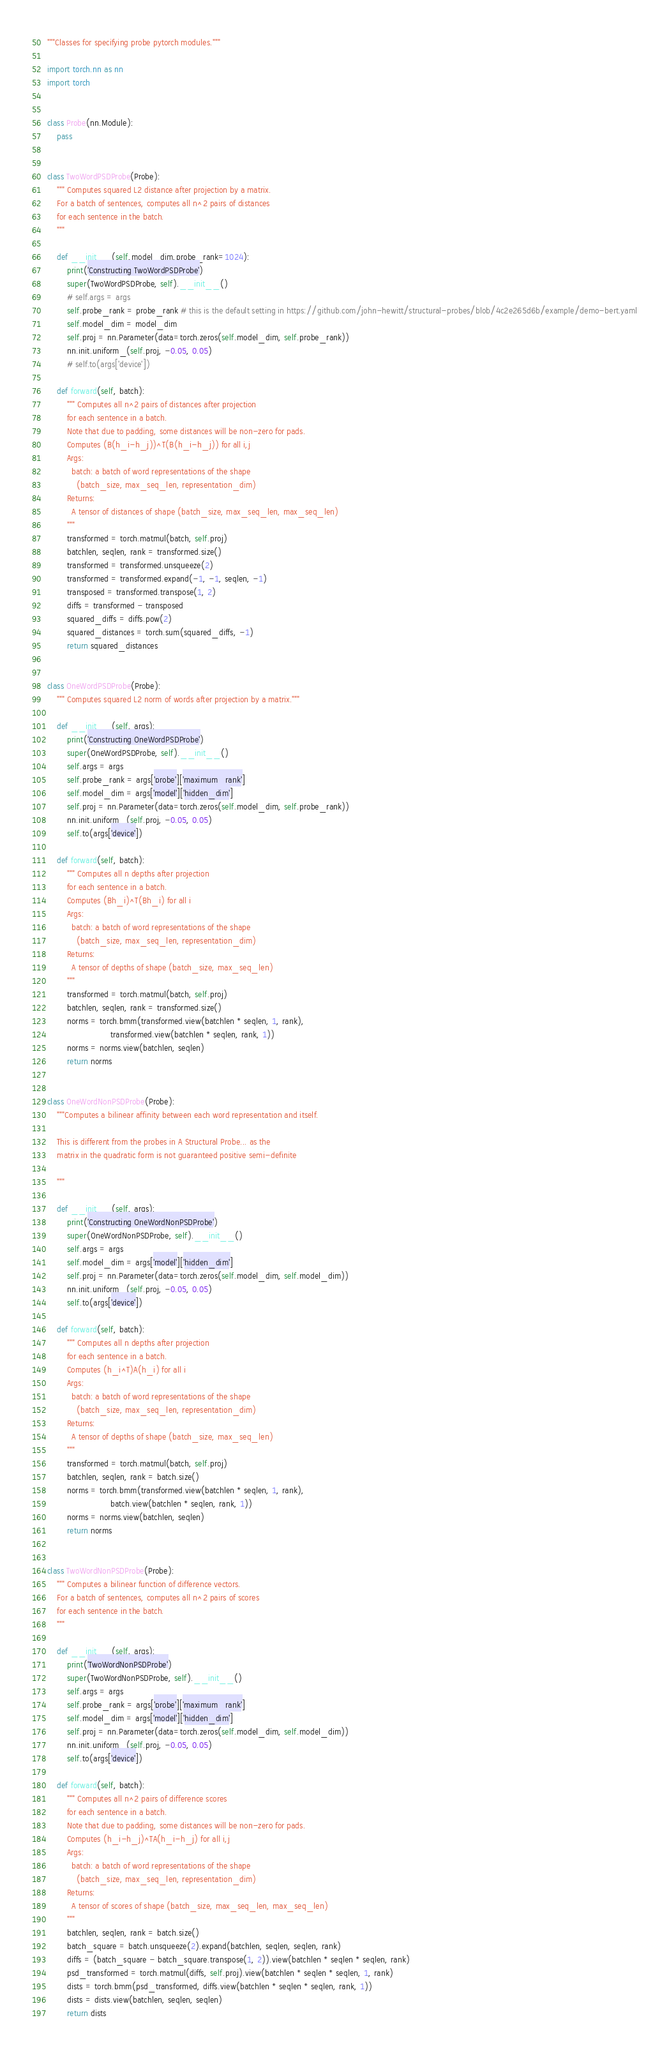<code> <loc_0><loc_0><loc_500><loc_500><_Python_>"""Classes for specifying probe pytorch modules."""

import torch.nn as nn
import torch


class Probe(nn.Module):
    pass


class TwoWordPSDProbe(Probe):
    """ Computes squared L2 distance after projection by a matrix.
    For a batch of sentences, computes all n^2 pairs of distances
    for each sentence in the batch.
    """

    def __init__(self,model_dim,probe_rank=1024):
        print('Constructing TwoWordPSDProbe')
        super(TwoWordPSDProbe, self).__init__()
        # self.args = args
        self.probe_rank = probe_rank # this is the default setting in https://github.com/john-hewitt/structural-probes/blob/4c2e265d6b/example/demo-bert.yaml
        self.model_dim = model_dim
        self.proj = nn.Parameter(data=torch.zeros(self.model_dim, self.probe_rank))
        nn.init.uniform_(self.proj, -0.05, 0.05)
        # self.to(args['device'])

    def forward(self, batch):
        """ Computes all n^2 pairs of distances after projection
        for each sentence in a batch.
        Note that due to padding, some distances will be non-zero for pads.
        Computes (B(h_i-h_j))^T(B(h_i-h_j)) for all i,j
        Args:
          batch: a batch of word representations of the shape
            (batch_size, max_seq_len, representation_dim)
        Returns:
          A tensor of distances of shape (batch_size, max_seq_len, max_seq_len)
        """
        transformed = torch.matmul(batch, self.proj)
        batchlen, seqlen, rank = transformed.size()
        transformed = transformed.unsqueeze(2)
        transformed = transformed.expand(-1, -1, seqlen, -1)
        transposed = transformed.transpose(1, 2)
        diffs = transformed - transposed
        squared_diffs = diffs.pow(2)
        squared_distances = torch.sum(squared_diffs, -1)
        return squared_distances


class OneWordPSDProbe(Probe):
    """ Computes squared L2 norm of words after projection by a matrix."""

    def __init__(self, args):
        print('Constructing OneWordPSDProbe')
        super(OneWordPSDProbe, self).__init__()
        self.args = args
        self.probe_rank = args['probe']['maximum_rank']
        self.model_dim = args['model']['hidden_dim']
        self.proj = nn.Parameter(data=torch.zeros(self.model_dim, self.probe_rank))
        nn.init.uniform_(self.proj, -0.05, 0.05)
        self.to(args['device'])

    def forward(self, batch):
        """ Computes all n depths after projection
        for each sentence in a batch.
        Computes (Bh_i)^T(Bh_i) for all i
        Args:
          batch: a batch of word representations of the shape
            (batch_size, max_seq_len, representation_dim)
        Returns:
          A tensor of depths of shape (batch_size, max_seq_len)
        """
        transformed = torch.matmul(batch, self.proj)
        batchlen, seqlen, rank = transformed.size()
        norms = torch.bmm(transformed.view(batchlen * seqlen, 1, rank),
                          transformed.view(batchlen * seqlen, rank, 1))
        norms = norms.view(batchlen, seqlen)
        return norms


class OneWordNonPSDProbe(Probe):
    """Computes a bilinear affinity between each word representation and itself.

    This is different from the probes in A Structural Probe... as the
    matrix in the quadratic form is not guaranteed positive semi-definite

    """

    def __init__(self, args):
        print('Constructing OneWordNonPSDProbe')
        super(OneWordNonPSDProbe, self).__init__()
        self.args = args
        self.model_dim = args['model']['hidden_dim']
        self.proj = nn.Parameter(data=torch.zeros(self.model_dim, self.model_dim))
        nn.init.uniform_(self.proj, -0.05, 0.05)
        self.to(args['device'])

    def forward(self, batch):
        """ Computes all n depths after projection
        for each sentence in a batch.
        Computes (h_i^T)A(h_i) for all i
        Args:
          batch: a batch of word representations of the shape
            (batch_size, max_seq_len, representation_dim)
        Returns:
          A tensor of depths of shape (batch_size, max_seq_len)
        """
        transformed = torch.matmul(batch, self.proj)
        batchlen, seqlen, rank = batch.size()
        norms = torch.bmm(transformed.view(batchlen * seqlen, 1, rank),
                          batch.view(batchlen * seqlen, rank, 1))
        norms = norms.view(batchlen, seqlen)
        return norms


class TwoWordNonPSDProbe(Probe):
    """ Computes a bilinear function of difference vectors.
    For a batch of sentences, computes all n^2 pairs of scores
    for each sentence in the batch.
    """

    def __init__(self, args):
        print('TwoWordNonPSDProbe')
        super(TwoWordNonPSDProbe, self).__init__()
        self.args = args
        self.probe_rank = args['probe']['maximum_rank']
        self.model_dim = args['model']['hidden_dim']
        self.proj = nn.Parameter(data=torch.zeros(self.model_dim, self.model_dim))
        nn.init.uniform_(self.proj, -0.05, 0.05)
        self.to(args['device'])

    def forward(self, batch):
        """ Computes all n^2 pairs of difference scores
        for each sentence in a batch.
        Note that due to padding, some distances will be non-zero for pads.
        Computes (h_i-h_j)^TA(h_i-h_j) for all i,j
        Args:
          batch: a batch of word representations of the shape
            (batch_size, max_seq_len, representation_dim)
        Returns:
          A tensor of scores of shape (batch_size, max_seq_len, max_seq_len)
        """
        batchlen, seqlen, rank = batch.size()
        batch_square = batch.unsqueeze(2).expand(batchlen, seqlen, seqlen, rank)
        diffs = (batch_square - batch_square.transpose(1, 2)).view(batchlen * seqlen * seqlen, rank)
        psd_transformed = torch.matmul(diffs, self.proj).view(batchlen * seqlen * seqlen, 1, rank)
        dists = torch.bmm(psd_transformed, diffs.view(batchlen * seqlen * seqlen, rank, 1))
        dists = dists.view(batchlen, seqlen, seqlen)
        return dists</code> 